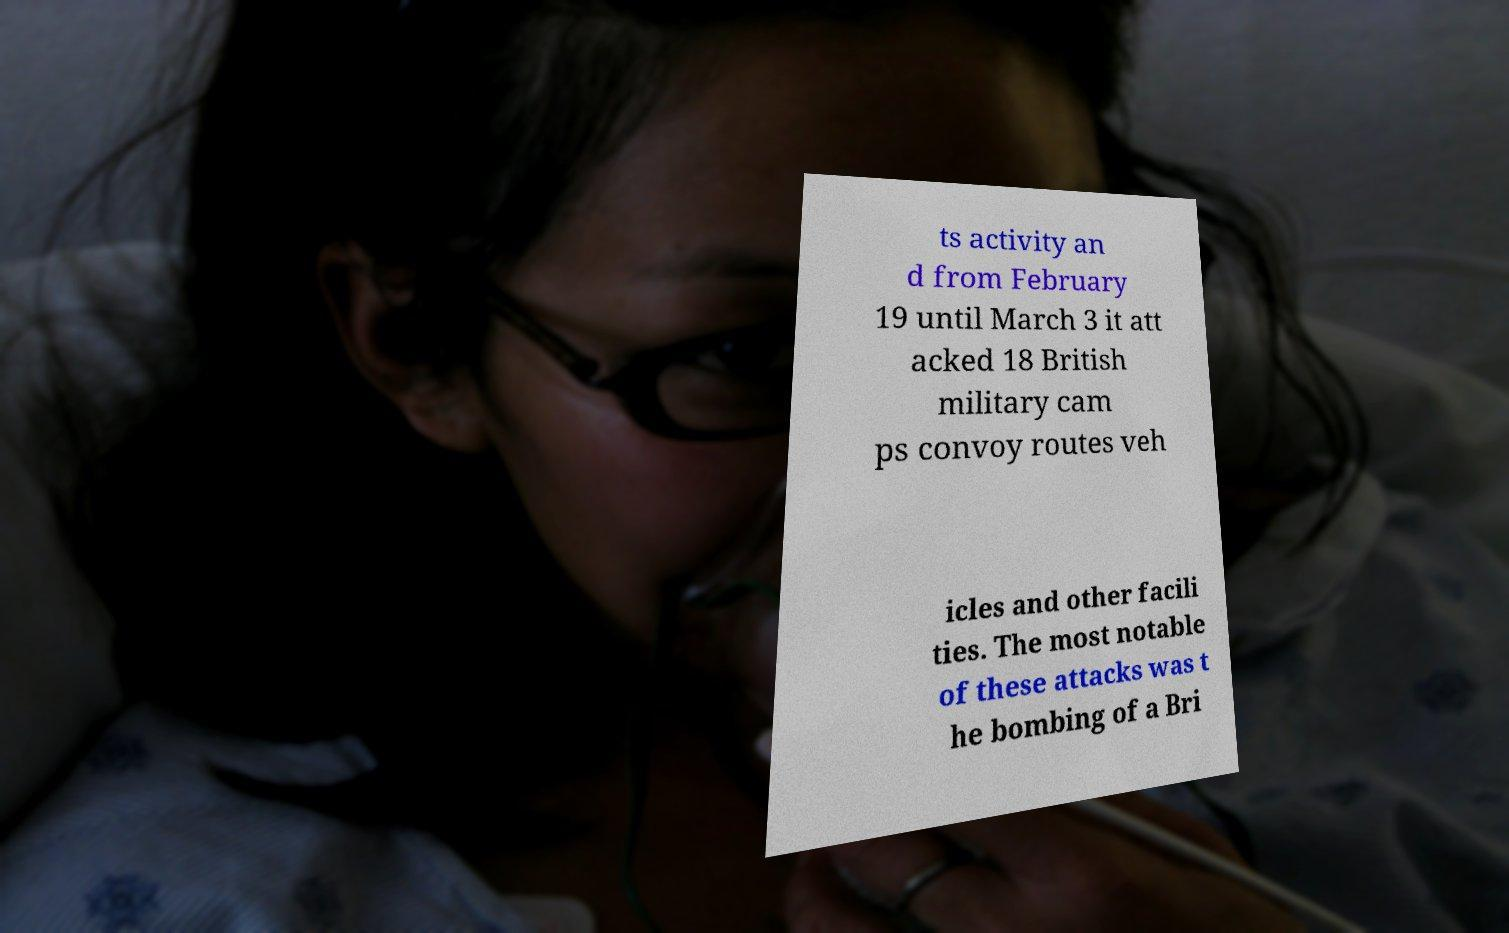Could you extract and type out the text from this image? ts activity an d from February 19 until March 3 it att acked 18 British military cam ps convoy routes veh icles and other facili ties. The most notable of these attacks was t he bombing of a Bri 